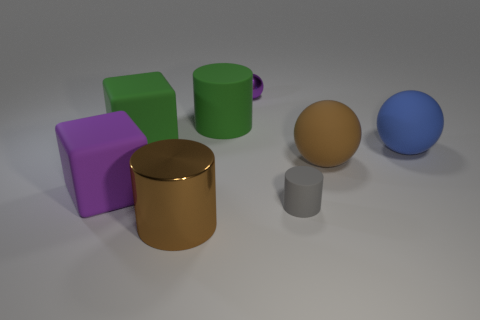Add 2 large red metal cubes. How many objects exist? 10 Subtract all blocks. How many objects are left? 6 Add 5 big blue matte spheres. How many big blue matte spheres are left? 6 Add 6 large spheres. How many large spheres exist? 8 Subtract 1 brown balls. How many objects are left? 7 Subtract all large metallic objects. Subtract all purple metallic balls. How many objects are left? 6 